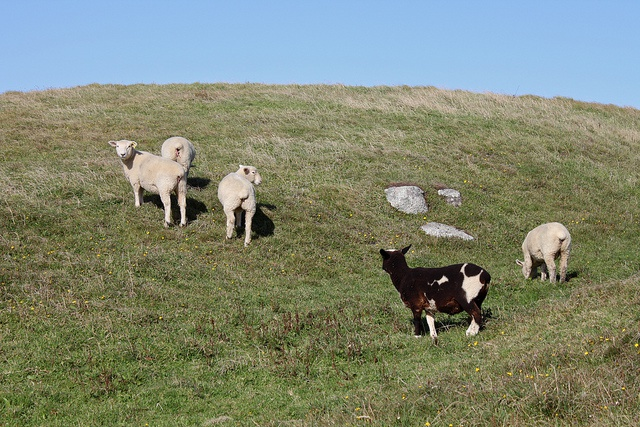Describe the objects in this image and their specific colors. I can see sheep in lightblue, black, lightgray, maroon, and darkgreen tones, cow in lightblue, black, lightgray, maroon, and gray tones, sheep in lightblue, tan, lightgray, and darkgray tones, sheep in lightblue, tan, darkgray, and black tones, and sheep in lightblue, lightgray, tan, and darkgray tones in this image. 